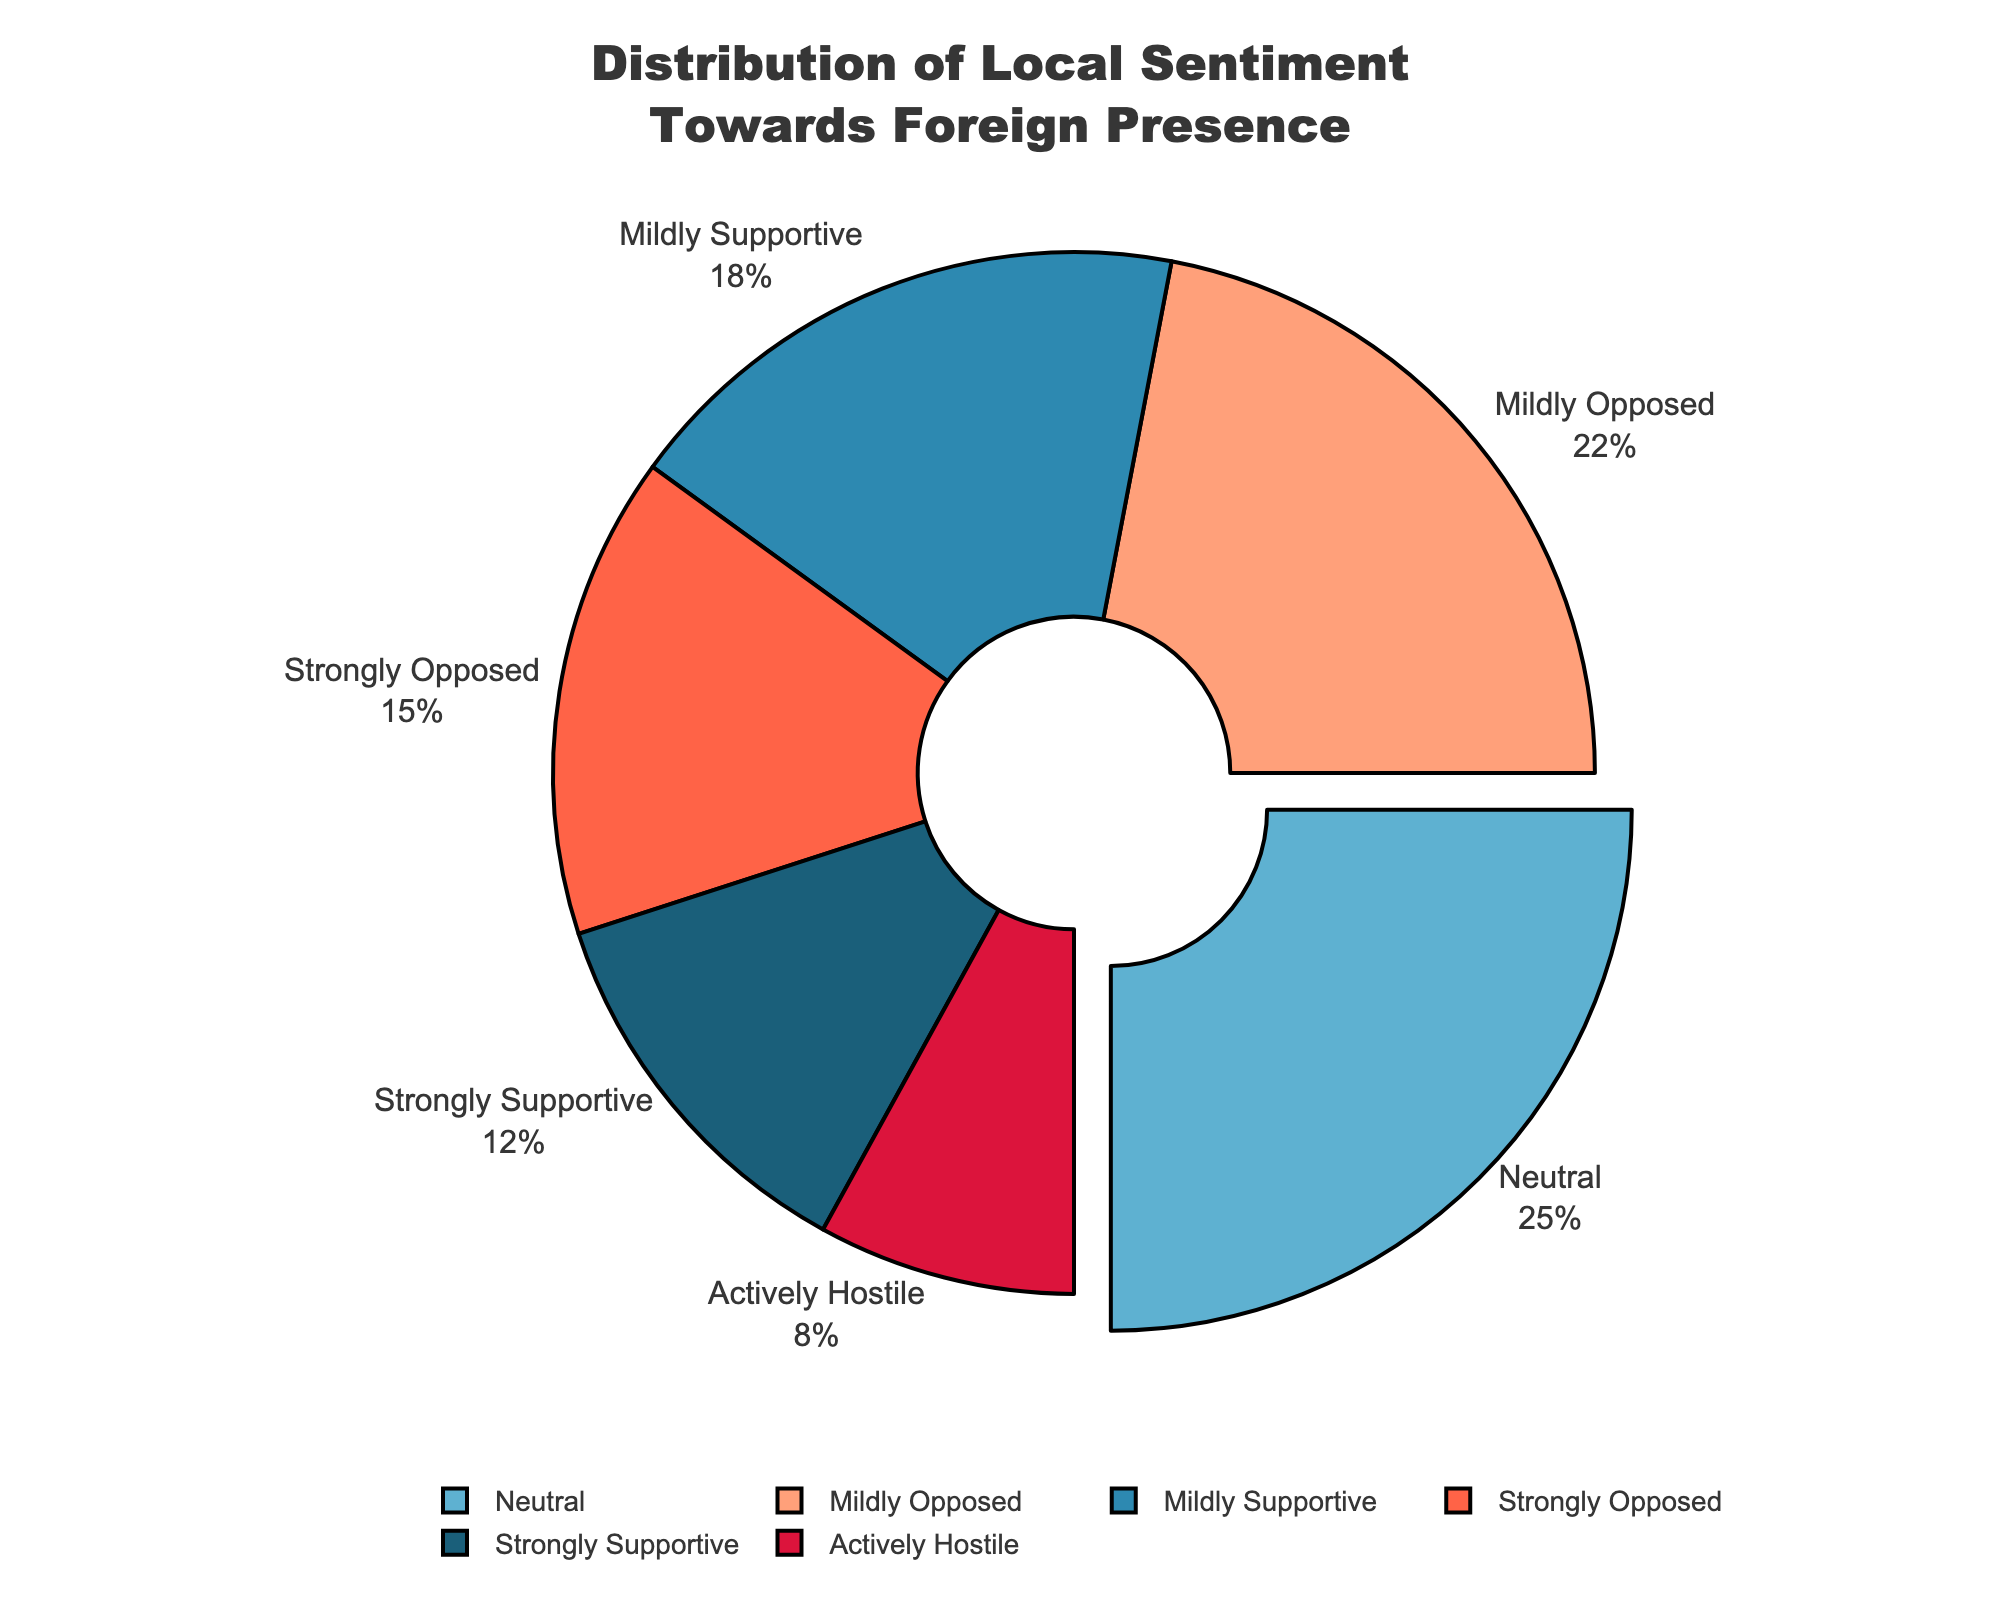What sentiment category has the highest percentage? The pie chart shows that the Neutral category has the slice with the largest percentage, and it's also slightly pulled out.
Answer: Neutral What is the combined percentage of the opposed categories, including Mildly Opposed, Strongly Opposed, and Actively Hostile? Add the percentages of Mildly Opposed (22%), Strongly Opposed (15%), and Actively Hostile (8%) together: 22 + 15 + 8 = 45%.
Answer: 45% Which sentiment category appears to be the least supportive or most hostile? The Actively Hostile category has the smallest slice in the pie chart, showing the least supportive sentiment at 8%.
Answer: Actively Hostile How much more supportive is the combined support (Strongly Supportive and Mildly Supportive) compared to the active hostility? Add the percentages of Strongly Supportive (12%) and Mildly Supportive (18%) to get the total supportive percentage (12+18=30%). Then subtract the Actively Hostile percentage (8%) from the total supportive percentage: 30 - 8 = 22%.
Answer: 22% Which category has a higher percentage, Strongly Opposed or Strongly Supportive? Comparing the slices for Strongly Opposed (15%) and Strongly Supportive (12%), we see that Strongly Opposed has a higher percentage.
Answer: Strongly Opposed How many percentage points separate Neutral and Mildly Opposed sentiments? Subtract the percentage of Mildly Opposed (22%) from Neutral (25%). 25 - 22 = 3 percentage points.
Answer: 3 What percentage of the population is either supportive (Strongly Supportive or Mildly Supportive) or neutral towards the foreign presence? Add the percentages of Strongly Supportive (12%), Mildly Supportive (18%), and Neutral (25%): 12 + 18 + 25 = 55%.
Answer: 55% What is the difference in percentage between the most supportive sentiment (Strongly Supportive) and the strongly opposed sentiment (Strongly Opposed)? Subtract the percentage of Strongly Opposed (15%) from Strongly Supportive (12%). 12 - 15 = -3%.
Answer: -3% Which slice of the pie chart corresponds to the color red? By visual analysis, the color red is used for the Strongly Opposed category.
Answer: Strongly Opposed Which category falls exactly between the Strongly Supportive and Strongly Opposed sentiments in terms of percentage? The Strongly Supportive percentage is 12% and the Strongly Opposed percentage is 15%; the closest midpoint sentiment percentage is Mildly Supportive at 18%.
Answer: Mildly Supportive 